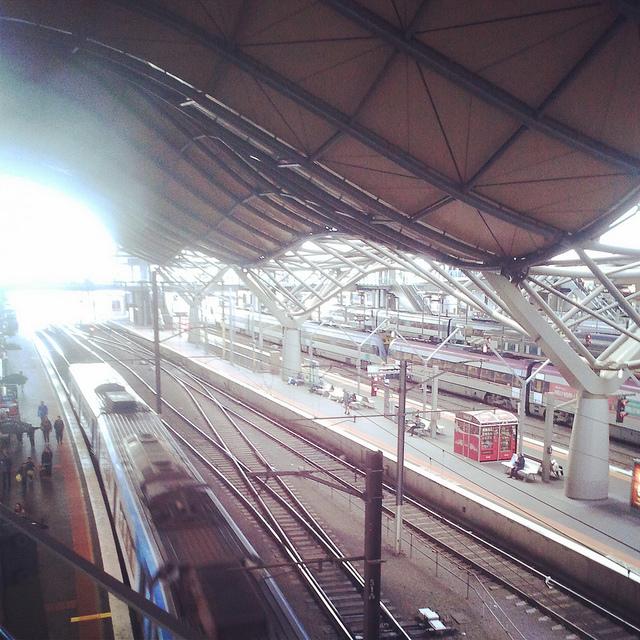How many people can you see?
Keep it brief. 7. Would a person rather ride on or in the morning vehicle?
Concise answer only. In. What is the setting?
Short answer required. Train station. 